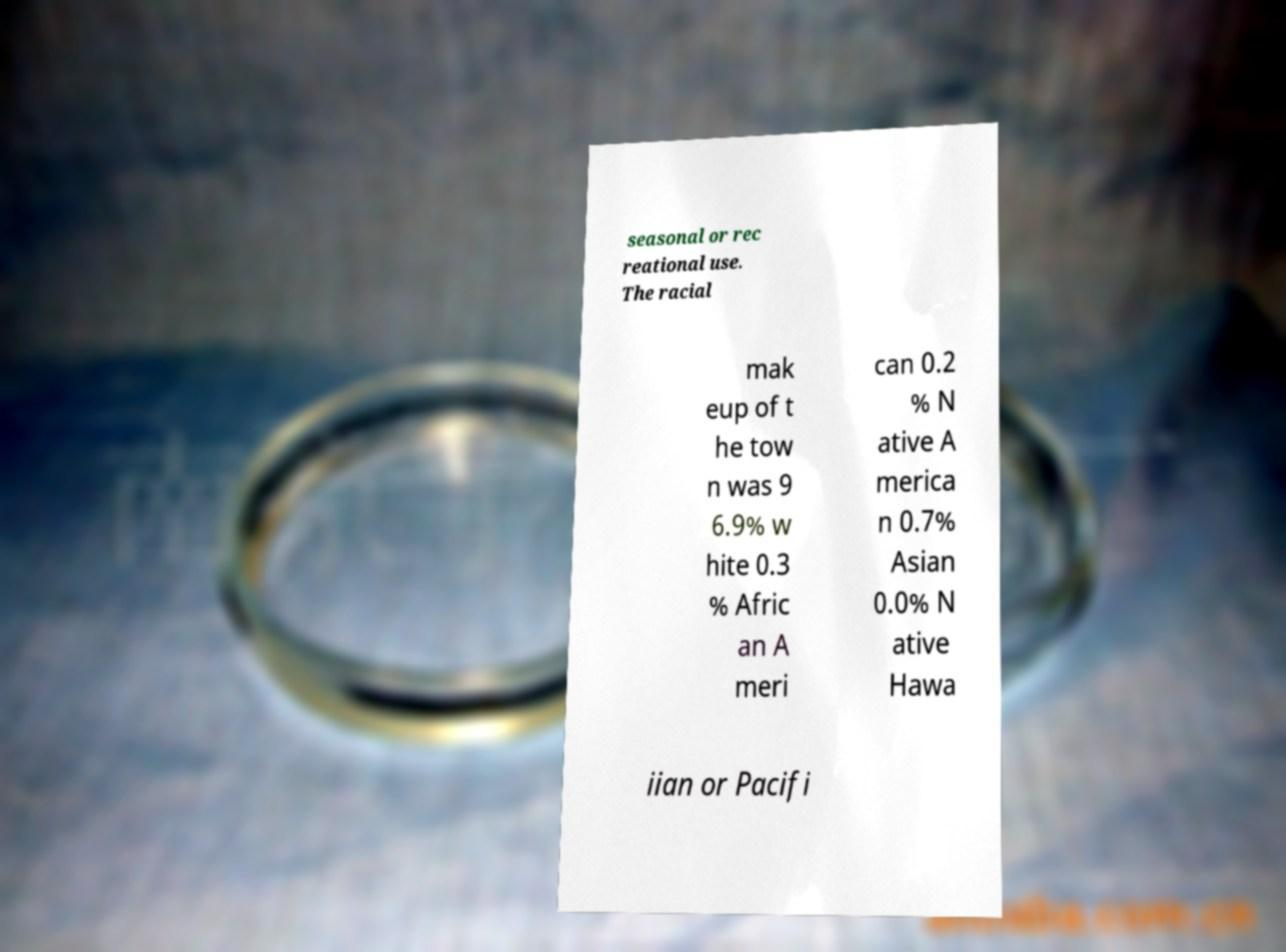Could you assist in decoding the text presented in this image and type it out clearly? seasonal or rec reational use. The racial mak eup of t he tow n was 9 6.9% w hite 0.3 % Afric an A meri can 0.2 % N ative A merica n 0.7% Asian 0.0% N ative Hawa iian or Pacifi 